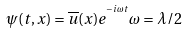Convert formula to latex. <formula><loc_0><loc_0><loc_500><loc_500>\psi ( t , x ) = \overline { u } ( x ) e ^ { ^ { - i \omega t } } \omega = \lambda / 2</formula> 